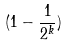Convert formula to latex. <formula><loc_0><loc_0><loc_500><loc_500>( 1 - \frac { 1 } { 2 ^ { k } } )</formula> 